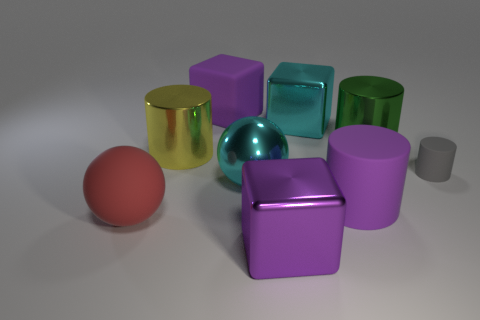Subtract all red cylinders. Subtract all gray spheres. How many cylinders are left? 4 Subtract all cylinders. How many objects are left? 5 Subtract all shiny cylinders. Subtract all matte objects. How many objects are left? 3 Add 7 gray rubber cylinders. How many gray rubber cylinders are left? 8 Add 1 red matte cylinders. How many red matte cylinders exist? 1 Subtract 1 red balls. How many objects are left? 8 